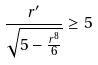Convert formula to latex. <formula><loc_0><loc_0><loc_500><loc_500>\frac { r ^ { \prime } } { \sqrt { 5 - \frac { r ^ { 8 } } { 6 } } } \geq 5</formula> 